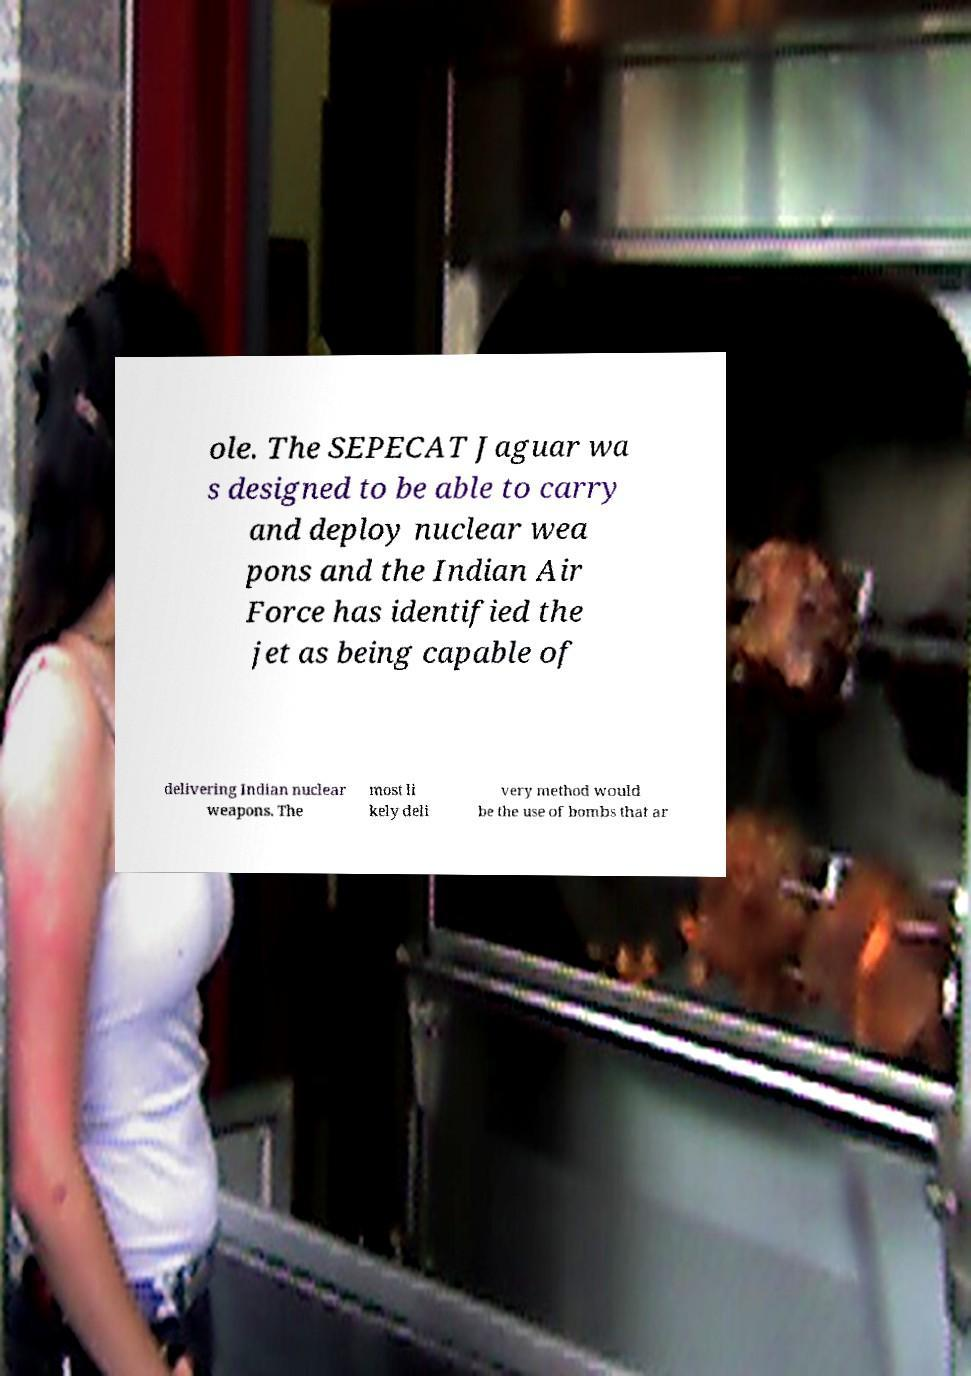For documentation purposes, I need the text within this image transcribed. Could you provide that? ole. The SEPECAT Jaguar wa s designed to be able to carry and deploy nuclear wea pons and the Indian Air Force has identified the jet as being capable of delivering Indian nuclear weapons. The most li kely deli very method would be the use of bombs that ar 